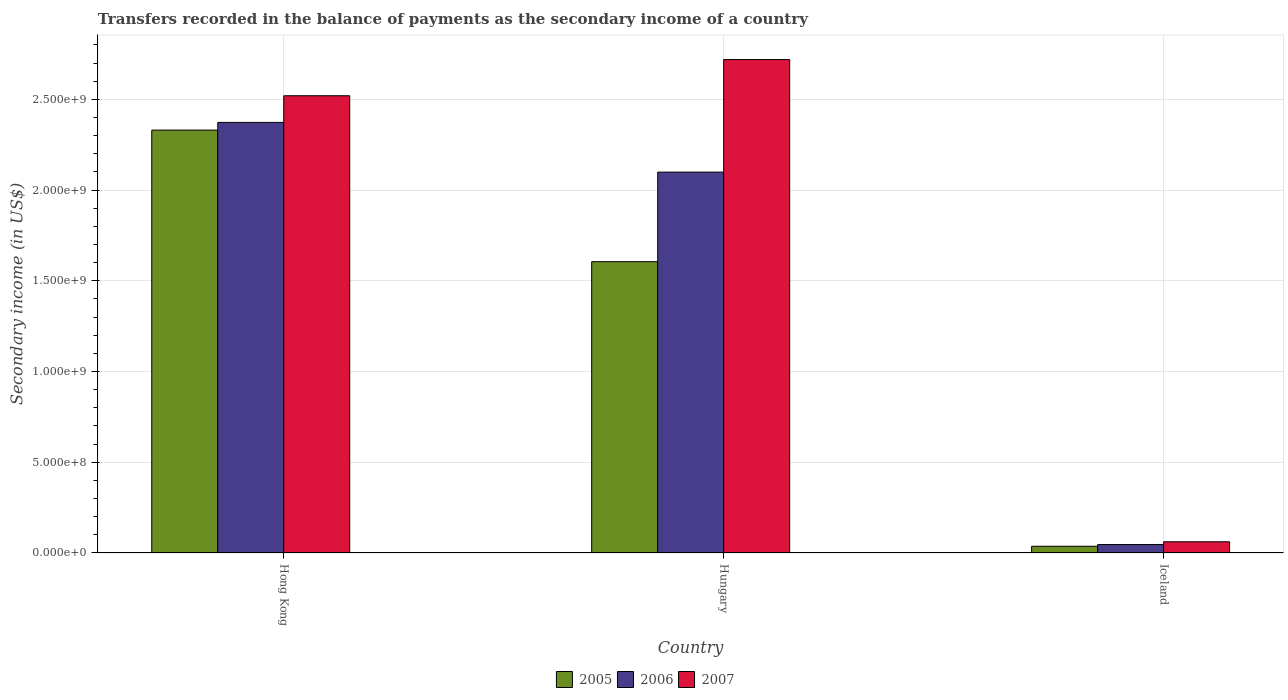How many different coloured bars are there?
Provide a succinct answer. 3. Are the number of bars on each tick of the X-axis equal?
Offer a very short reply. Yes. How many bars are there on the 3rd tick from the left?
Your response must be concise. 3. What is the label of the 2nd group of bars from the left?
Your answer should be very brief. Hungary. What is the secondary income of in 2006 in Hungary?
Offer a terse response. 2.10e+09. Across all countries, what is the maximum secondary income of in 2005?
Keep it short and to the point. 2.33e+09. Across all countries, what is the minimum secondary income of in 2007?
Your response must be concise. 6.18e+07. In which country was the secondary income of in 2005 maximum?
Your answer should be very brief. Hong Kong. What is the total secondary income of in 2005 in the graph?
Your answer should be very brief. 3.97e+09. What is the difference between the secondary income of in 2007 in Hong Kong and that in Hungary?
Provide a succinct answer. -1.99e+08. What is the difference between the secondary income of in 2006 in Hungary and the secondary income of in 2007 in Hong Kong?
Ensure brevity in your answer.  -4.21e+08. What is the average secondary income of in 2006 per country?
Offer a terse response. 1.51e+09. What is the difference between the secondary income of of/in 2005 and secondary income of of/in 2006 in Hungary?
Keep it short and to the point. -4.94e+08. What is the ratio of the secondary income of in 2006 in Hong Kong to that in Hungary?
Offer a terse response. 1.13. What is the difference between the highest and the second highest secondary income of in 2007?
Offer a terse response. -2.46e+09. What is the difference between the highest and the lowest secondary income of in 2007?
Your answer should be very brief. 2.66e+09. What does the 3rd bar from the left in Hong Kong represents?
Your answer should be very brief. 2007. What does the 3rd bar from the right in Hong Kong represents?
Make the answer very short. 2005. Is it the case that in every country, the sum of the secondary income of in 2005 and secondary income of in 2006 is greater than the secondary income of in 2007?
Make the answer very short. Yes. What is the difference between two consecutive major ticks on the Y-axis?
Provide a succinct answer. 5.00e+08. Does the graph contain any zero values?
Give a very brief answer. No. Where does the legend appear in the graph?
Give a very brief answer. Bottom center. How many legend labels are there?
Your answer should be compact. 3. What is the title of the graph?
Your answer should be compact. Transfers recorded in the balance of payments as the secondary income of a country. What is the label or title of the X-axis?
Ensure brevity in your answer.  Country. What is the label or title of the Y-axis?
Your answer should be very brief. Secondary income (in US$). What is the Secondary income (in US$) in 2005 in Hong Kong?
Make the answer very short. 2.33e+09. What is the Secondary income (in US$) of 2006 in Hong Kong?
Your response must be concise. 2.37e+09. What is the Secondary income (in US$) of 2007 in Hong Kong?
Provide a short and direct response. 2.52e+09. What is the Secondary income (in US$) of 2005 in Hungary?
Give a very brief answer. 1.61e+09. What is the Secondary income (in US$) in 2006 in Hungary?
Your answer should be very brief. 2.10e+09. What is the Secondary income (in US$) of 2007 in Hungary?
Offer a very short reply. 2.72e+09. What is the Secondary income (in US$) of 2005 in Iceland?
Your answer should be very brief. 3.70e+07. What is the Secondary income (in US$) of 2006 in Iceland?
Provide a short and direct response. 4.65e+07. What is the Secondary income (in US$) in 2007 in Iceland?
Ensure brevity in your answer.  6.18e+07. Across all countries, what is the maximum Secondary income (in US$) in 2005?
Offer a terse response. 2.33e+09. Across all countries, what is the maximum Secondary income (in US$) of 2006?
Keep it short and to the point. 2.37e+09. Across all countries, what is the maximum Secondary income (in US$) of 2007?
Keep it short and to the point. 2.72e+09. Across all countries, what is the minimum Secondary income (in US$) of 2005?
Offer a terse response. 3.70e+07. Across all countries, what is the minimum Secondary income (in US$) in 2006?
Ensure brevity in your answer.  4.65e+07. Across all countries, what is the minimum Secondary income (in US$) of 2007?
Offer a terse response. 6.18e+07. What is the total Secondary income (in US$) in 2005 in the graph?
Your answer should be very brief. 3.97e+09. What is the total Secondary income (in US$) in 2006 in the graph?
Provide a short and direct response. 4.52e+09. What is the total Secondary income (in US$) in 2007 in the graph?
Your answer should be compact. 5.30e+09. What is the difference between the Secondary income (in US$) in 2005 in Hong Kong and that in Hungary?
Your answer should be compact. 7.25e+08. What is the difference between the Secondary income (in US$) of 2006 in Hong Kong and that in Hungary?
Your response must be concise. 2.74e+08. What is the difference between the Secondary income (in US$) in 2007 in Hong Kong and that in Hungary?
Offer a terse response. -1.99e+08. What is the difference between the Secondary income (in US$) of 2005 in Hong Kong and that in Iceland?
Provide a succinct answer. 2.29e+09. What is the difference between the Secondary income (in US$) of 2006 in Hong Kong and that in Iceland?
Keep it short and to the point. 2.33e+09. What is the difference between the Secondary income (in US$) in 2007 in Hong Kong and that in Iceland?
Offer a very short reply. 2.46e+09. What is the difference between the Secondary income (in US$) of 2005 in Hungary and that in Iceland?
Ensure brevity in your answer.  1.57e+09. What is the difference between the Secondary income (in US$) of 2006 in Hungary and that in Iceland?
Offer a terse response. 2.05e+09. What is the difference between the Secondary income (in US$) in 2007 in Hungary and that in Iceland?
Make the answer very short. 2.66e+09. What is the difference between the Secondary income (in US$) in 2005 in Hong Kong and the Secondary income (in US$) in 2006 in Hungary?
Give a very brief answer. 2.32e+08. What is the difference between the Secondary income (in US$) of 2005 in Hong Kong and the Secondary income (in US$) of 2007 in Hungary?
Ensure brevity in your answer.  -3.89e+08. What is the difference between the Secondary income (in US$) of 2006 in Hong Kong and the Secondary income (in US$) of 2007 in Hungary?
Ensure brevity in your answer.  -3.47e+08. What is the difference between the Secondary income (in US$) in 2005 in Hong Kong and the Secondary income (in US$) in 2006 in Iceland?
Keep it short and to the point. 2.28e+09. What is the difference between the Secondary income (in US$) in 2005 in Hong Kong and the Secondary income (in US$) in 2007 in Iceland?
Offer a terse response. 2.27e+09. What is the difference between the Secondary income (in US$) in 2006 in Hong Kong and the Secondary income (in US$) in 2007 in Iceland?
Make the answer very short. 2.31e+09. What is the difference between the Secondary income (in US$) in 2005 in Hungary and the Secondary income (in US$) in 2006 in Iceland?
Your response must be concise. 1.56e+09. What is the difference between the Secondary income (in US$) in 2005 in Hungary and the Secondary income (in US$) in 2007 in Iceland?
Provide a succinct answer. 1.54e+09. What is the difference between the Secondary income (in US$) in 2006 in Hungary and the Secondary income (in US$) in 2007 in Iceland?
Your response must be concise. 2.04e+09. What is the average Secondary income (in US$) of 2005 per country?
Your answer should be very brief. 1.32e+09. What is the average Secondary income (in US$) in 2006 per country?
Provide a short and direct response. 1.51e+09. What is the average Secondary income (in US$) in 2007 per country?
Your answer should be compact. 1.77e+09. What is the difference between the Secondary income (in US$) of 2005 and Secondary income (in US$) of 2006 in Hong Kong?
Give a very brief answer. -4.24e+07. What is the difference between the Secondary income (in US$) of 2005 and Secondary income (in US$) of 2007 in Hong Kong?
Your answer should be very brief. -1.89e+08. What is the difference between the Secondary income (in US$) of 2006 and Secondary income (in US$) of 2007 in Hong Kong?
Your answer should be very brief. -1.47e+08. What is the difference between the Secondary income (in US$) in 2005 and Secondary income (in US$) in 2006 in Hungary?
Provide a short and direct response. -4.94e+08. What is the difference between the Secondary income (in US$) of 2005 and Secondary income (in US$) of 2007 in Hungary?
Provide a succinct answer. -1.11e+09. What is the difference between the Secondary income (in US$) in 2006 and Secondary income (in US$) in 2007 in Hungary?
Provide a succinct answer. -6.20e+08. What is the difference between the Secondary income (in US$) of 2005 and Secondary income (in US$) of 2006 in Iceland?
Offer a terse response. -9.48e+06. What is the difference between the Secondary income (in US$) in 2005 and Secondary income (in US$) in 2007 in Iceland?
Your answer should be very brief. -2.48e+07. What is the difference between the Secondary income (in US$) in 2006 and Secondary income (in US$) in 2007 in Iceland?
Offer a terse response. -1.53e+07. What is the ratio of the Secondary income (in US$) of 2005 in Hong Kong to that in Hungary?
Your answer should be compact. 1.45. What is the ratio of the Secondary income (in US$) in 2006 in Hong Kong to that in Hungary?
Offer a very short reply. 1.13. What is the ratio of the Secondary income (in US$) in 2007 in Hong Kong to that in Hungary?
Your answer should be compact. 0.93. What is the ratio of the Secondary income (in US$) in 2005 in Hong Kong to that in Iceland?
Make the answer very short. 63.04. What is the ratio of the Secondary income (in US$) of 2006 in Hong Kong to that in Iceland?
Make the answer very short. 51.09. What is the ratio of the Secondary income (in US$) of 2007 in Hong Kong to that in Iceland?
Your answer should be very brief. 40.8. What is the ratio of the Secondary income (in US$) in 2005 in Hungary to that in Iceland?
Offer a terse response. 43.42. What is the ratio of the Secondary income (in US$) in 2006 in Hungary to that in Iceland?
Provide a succinct answer. 45.19. What is the ratio of the Secondary income (in US$) in 2007 in Hungary to that in Iceland?
Make the answer very short. 44.03. What is the difference between the highest and the second highest Secondary income (in US$) of 2005?
Offer a terse response. 7.25e+08. What is the difference between the highest and the second highest Secondary income (in US$) in 2006?
Your answer should be very brief. 2.74e+08. What is the difference between the highest and the second highest Secondary income (in US$) of 2007?
Ensure brevity in your answer.  1.99e+08. What is the difference between the highest and the lowest Secondary income (in US$) of 2005?
Provide a short and direct response. 2.29e+09. What is the difference between the highest and the lowest Secondary income (in US$) in 2006?
Your answer should be very brief. 2.33e+09. What is the difference between the highest and the lowest Secondary income (in US$) in 2007?
Offer a terse response. 2.66e+09. 